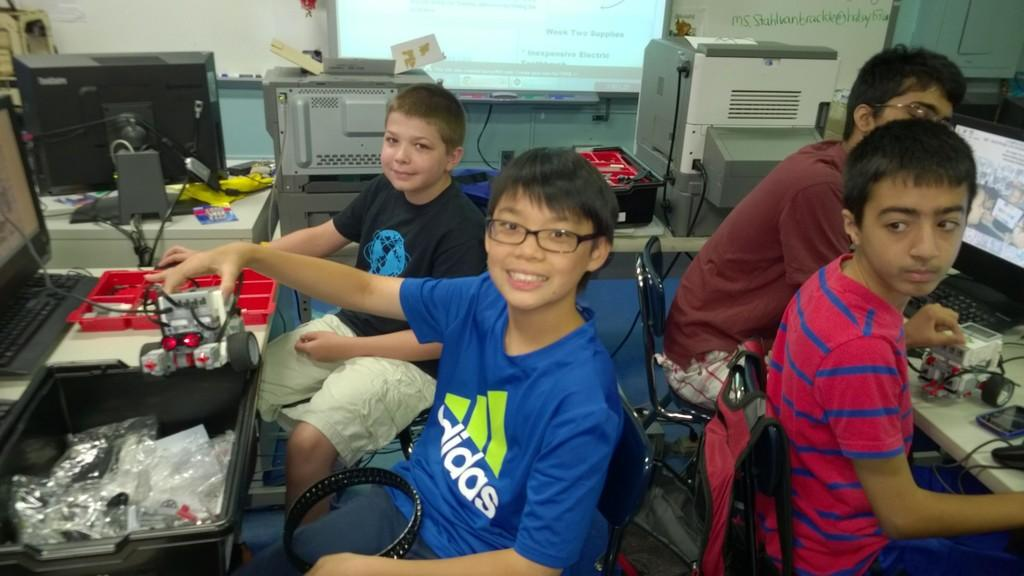What electronic devices are visible in the image? There are computers in the image. How many boys are present in the image? There are 4 boys in the image. What are the boys doing in the image? The boys appear to be working on a motor car. What are the boys sitting on while working on the motor car? The boys are sitting on chairs. What type of bell can be heard ringing in the image? There is no bell present in the image, and therefore no sound can be heard. 